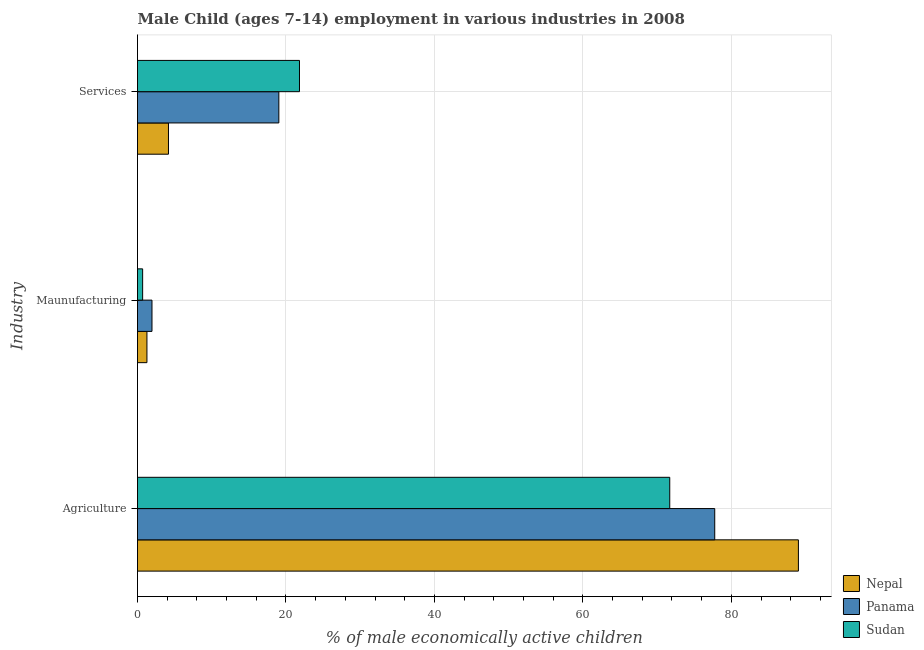How many different coloured bars are there?
Ensure brevity in your answer.  3. How many groups of bars are there?
Provide a succinct answer. 3. Are the number of bars per tick equal to the number of legend labels?
Ensure brevity in your answer.  Yes. Are the number of bars on each tick of the Y-axis equal?
Make the answer very short. Yes. How many bars are there on the 1st tick from the top?
Offer a terse response. 3. How many bars are there on the 3rd tick from the bottom?
Your response must be concise. 3. What is the label of the 2nd group of bars from the top?
Give a very brief answer. Maunufacturing. What is the percentage of economically active children in services in Panama?
Keep it short and to the point. 19.04. Across all countries, what is the maximum percentage of economically active children in services?
Provide a short and direct response. 21.82. Across all countries, what is the minimum percentage of economically active children in services?
Your answer should be very brief. 4.17. In which country was the percentage of economically active children in agriculture maximum?
Offer a terse response. Nepal. In which country was the percentage of economically active children in services minimum?
Your response must be concise. Nepal. What is the total percentage of economically active children in agriculture in the graph?
Ensure brevity in your answer.  238.49. What is the difference between the percentage of economically active children in manufacturing in Sudan and that in Nepal?
Ensure brevity in your answer.  -0.58. What is the difference between the percentage of economically active children in agriculture in Sudan and the percentage of economically active children in services in Nepal?
Your response must be concise. 67.53. What is the average percentage of economically active children in manufacturing per country?
Your response must be concise. 1.3. In how many countries, is the percentage of economically active children in services greater than 36 %?
Your answer should be compact. 0. What is the ratio of the percentage of economically active children in agriculture in Nepal to that in Sudan?
Provide a succinct answer. 1.24. Is the percentage of economically active children in agriculture in Panama less than that in Sudan?
Provide a short and direct response. No. What is the difference between the highest and the second highest percentage of economically active children in services?
Your answer should be very brief. 2.78. What is the difference between the highest and the lowest percentage of economically active children in manufacturing?
Offer a terse response. 1.26. Is the sum of the percentage of economically active children in manufacturing in Nepal and Panama greater than the maximum percentage of economically active children in services across all countries?
Provide a short and direct response. No. What does the 1st bar from the top in Maunufacturing represents?
Keep it short and to the point. Sudan. What does the 1st bar from the bottom in Maunufacturing represents?
Keep it short and to the point. Nepal. Is it the case that in every country, the sum of the percentage of economically active children in agriculture and percentage of economically active children in manufacturing is greater than the percentage of economically active children in services?
Ensure brevity in your answer.  Yes. How many bars are there?
Make the answer very short. 9. Are all the bars in the graph horizontal?
Provide a succinct answer. Yes. What is the difference between two consecutive major ticks on the X-axis?
Give a very brief answer. 20. Are the values on the major ticks of X-axis written in scientific E-notation?
Ensure brevity in your answer.  No. Does the graph contain grids?
Provide a succinct answer. Yes. Where does the legend appear in the graph?
Your answer should be very brief. Bottom right. How are the legend labels stacked?
Provide a succinct answer. Vertical. What is the title of the graph?
Offer a very short reply. Male Child (ages 7-14) employment in various industries in 2008. What is the label or title of the X-axis?
Ensure brevity in your answer.  % of male economically active children. What is the label or title of the Y-axis?
Your response must be concise. Industry. What is the % of male economically active children in Nepal in Agriculture?
Offer a very short reply. 89.03. What is the % of male economically active children in Panama in Agriculture?
Provide a succinct answer. 77.76. What is the % of male economically active children of Sudan in Agriculture?
Ensure brevity in your answer.  71.7. What is the % of male economically active children of Nepal in Maunufacturing?
Make the answer very short. 1.27. What is the % of male economically active children in Panama in Maunufacturing?
Your answer should be very brief. 1.95. What is the % of male economically active children of Sudan in Maunufacturing?
Provide a succinct answer. 0.69. What is the % of male economically active children of Nepal in Services?
Provide a short and direct response. 4.17. What is the % of male economically active children of Panama in Services?
Make the answer very short. 19.04. What is the % of male economically active children of Sudan in Services?
Keep it short and to the point. 21.82. Across all Industry, what is the maximum % of male economically active children in Nepal?
Offer a terse response. 89.03. Across all Industry, what is the maximum % of male economically active children of Panama?
Ensure brevity in your answer.  77.76. Across all Industry, what is the maximum % of male economically active children in Sudan?
Your answer should be very brief. 71.7. Across all Industry, what is the minimum % of male economically active children in Nepal?
Give a very brief answer. 1.27. Across all Industry, what is the minimum % of male economically active children of Panama?
Ensure brevity in your answer.  1.95. Across all Industry, what is the minimum % of male economically active children of Sudan?
Make the answer very short. 0.69. What is the total % of male economically active children in Nepal in the graph?
Provide a succinct answer. 94.47. What is the total % of male economically active children in Panama in the graph?
Offer a terse response. 98.75. What is the total % of male economically active children in Sudan in the graph?
Make the answer very short. 94.21. What is the difference between the % of male economically active children in Nepal in Agriculture and that in Maunufacturing?
Keep it short and to the point. 87.76. What is the difference between the % of male economically active children of Panama in Agriculture and that in Maunufacturing?
Keep it short and to the point. 75.81. What is the difference between the % of male economically active children of Sudan in Agriculture and that in Maunufacturing?
Your answer should be compact. 71.01. What is the difference between the % of male economically active children in Nepal in Agriculture and that in Services?
Provide a short and direct response. 84.86. What is the difference between the % of male economically active children of Panama in Agriculture and that in Services?
Your answer should be very brief. 58.72. What is the difference between the % of male economically active children in Sudan in Agriculture and that in Services?
Offer a terse response. 49.88. What is the difference between the % of male economically active children in Nepal in Maunufacturing and that in Services?
Your response must be concise. -2.9. What is the difference between the % of male economically active children in Panama in Maunufacturing and that in Services?
Make the answer very short. -17.09. What is the difference between the % of male economically active children of Sudan in Maunufacturing and that in Services?
Your response must be concise. -21.13. What is the difference between the % of male economically active children in Nepal in Agriculture and the % of male economically active children in Panama in Maunufacturing?
Provide a short and direct response. 87.08. What is the difference between the % of male economically active children in Nepal in Agriculture and the % of male economically active children in Sudan in Maunufacturing?
Offer a very short reply. 88.34. What is the difference between the % of male economically active children in Panama in Agriculture and the % of male economically active children in Sudan in Maunufacturing?
Your response must be concise. 77.07. What is the difference between the % of male economically active children in Nepal in Agriculture and the % of male economically active children in Panama in Services?
Your answer should be compact. 69.99. What is the difference between the % of male economically active children in Nepal in Agriculture and the % of male economically active children in Sudan in Services?
Make the answer very short. 67.21. What is the difference between the % of male economically active children in Panama in Agriculture and the % of male economically active children in Sudan in Services?
Offer a very short reply. 55.94. What is the difference between the % of male economically active children of Nepal in Maunufacturing and the % of male economically active children of Panama in Services?
Ensure brevity in your answer.  -17.77. What is the difference between the % of male economically active children in Nepal in Maunufacturing and the % of male economically active children in Sudan in Services?
Make the answer very short. -20.55. What is the difference between the % of male economically active children in Panama in Maunufacturing and the % of male economically active children in Sudan in Services?
Offer a very short reply. -19.87. What is the average % of male economically active children of Nepal per Industry?
Your answer should be very brief. 31.49. What is the average % of male economically active children in Panama per Industry?
Provide a short and direct response. 32.92. What is the average % of male economically active children in Sudan per Industry?
Your answer should be compact. 31.4. What is the difference between the % of male economically active children in Nepal and % of male economically active children in Panama in Agriculture?
Your answer should be compact. 11.27. What is the difference between the % of male economically active children in Nepal and % of male economically active children in Sudan in Agriculture?
Your answer should be compact. 17.33. What is the difference between the % of male economically active children of Panama and % of male economically active children of Sudan in Agriculture?
Provide a short and direct response. 6.06. What is the difference between the % of male economically active children in Nepal and % of male economically active children in Panama in Maunufacturing?
Give a very brief answer. -0.68. What is the difference between the % of male economically active children in Nepal and % of male economically active children in Sudan in Maunufacturing?
Ensure brevity in your answer.  0.58. What is the difference between the % of male economically active children in Panama and % of male economically active children in Sudan in Maunufacturing?
Your response must be concise. 1.26. What is the difference between the % of male economically active children of Nepal and % of male economically active children of Panama in Services?
Your answer should be very brief. -14.87. What is the difference between the % of male economically active children of Nepal and % of male economically active children of Sudan in Services?
Ensure brevity in your answer.  -17.65. What is the difference between the % of male economically active children in Panama and % of male economically active children in Sudan in Services?
Ensure brevity in your answer.  -2.78. What is the ratio of the % of male economically active children of Nepal in Agriculture to that in Maunufacturing?
Your response must be concise. 70.1. What is the ratio of the % of male economically active children in Panama in Agriculture to that in Maunufacturing?
Ensure brevity in your answer.  39.88. What is the ratio of the % of male economically active children of Sudan in Agriculture to that in Maunufacturing?
Provide a succinct answer. 103.91. What is the ratio of the % of male economically active children of Nepal in Agriculture to that in Services?
Provide a short and direct response. 21.35. What is the ratio of the % of male economically active children of Panama in Agriculture to that in Services?
Make the answer very short. 4.08. What is the ratio of the % of male economically active children in Sudan in Agriculture to that in Services?
Your answer should be compact. 3.29. What is the ratio of the % of male economically active children of Nepal in Maunufacturing to that in Services?
Provide a succinct answer. 0.3. What is the ratio of the % of male economically active children in Panama in Maunufacturing to that in Services?
Your response must be concise. 0.1. What is the ratio of the % of male economically active children of Sudan in Maunufacturing to that in Services?
Your answer should be very brief. 0.03. What is the difference between the highest and the second highest % of male economically active children of Nepal?
Offer a very short reply. 84.86. What is the difference between the highest and the second highest % of male economically active children of Panama?
Your answer should be very brief. 58.72. What is the difference between the highest and the second highest % of male economically active children in Sudan?
Provide a short and direct response. 49.88. What is the difference between the highest and the lowest % of male economically active children of Nepal?
Provide a short and direct response. 87.76. What is the difference between the highest and the lowest % of male economically active children in Panama?
Keep it short and to the point. 75.81. What is the difference between the highest and the lowest % of male economically active children of Sudan?
Ensure brevity in your answer.  71.01. 